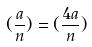Convert formula to latex. <formula><loc_0><loc_0><loc_500><loc_500>( \frac { a } { n } ) = ( \frac { 4 a } { n } )</formula> 